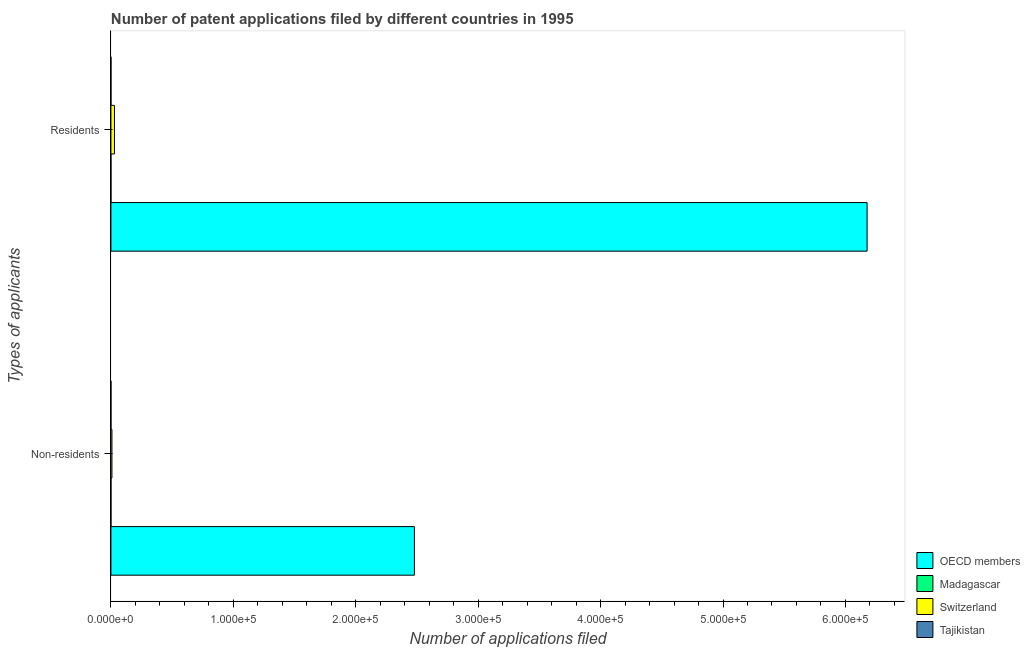How many different coloured bars are there?
Keep it short and to the point. 4. Are the number of bars per tick equal to the number of legend labels?
Offer a very short reply. Yes. Are the number of bars on each tick of the Y-axis equal?
Provide a succinct answer. Yes. How many bars are there on the 2nd tick from the top?
Give a very brief answer. 4. What is the label of the 2nd group of bars from the top?
Offer a terse response. Non-residents. What is the number of patent applications by non residents in OECD members?
Give a very brief answer. 2.48e+05. Across all countries, what is the maximum number of patent applications by residents?
Keep it short and to the point. 6.18e+05. Across all countries, what is the minimum number of patent applications by non residents?
Offer a very short reply. 16. In which country was the number of patent applications by non residents minimum?
Make the answer very short. Madagascar. What is the total number of patent applications by residents in the graph?
Give a very brief answer. 6.21e+05. What is the difference between the number of patent applications by non residents in Tajikistan and that in Switzerland?
Your response must be concise. -800. What is the difference between the number of patent applications by non residents in Switzerland and the number of patent applications by residents in OECD members?
Offer a terse response. -6.17e+05. What is the average number of patent applications by residents per country?
Give a very brief answer. 1.55e+05. What is the difference between the number of patent applications by residents and number of patent applications by non residents in OECD members?
Your answer should be very brief. 3.70e+05. In how many countries, is the number of patent applications by residents greater than 600000 ?
Your answer should be compact. 1. What is the ratio of the number of patent applications by residents in Madagascar to that in Switzerland?
Your answer should be compact. 0.01. Is the number of patent applications by residents in Tajikistan less than that in Madagascar?
Offer a very short reply. No. In how many countries, is the number of patent applications by non residents greater than the average number of patent applications by non residents taken over all countries?
Give a very brief answer. 1. What does the 2nd bar from the top in Residents represents?
Give a very brief answer. Switzerland. What does the 2nd bar from the bottom in Residents represents?
Provide a short and direct response. Madagascar. How many countries are there in the graph?
Your answer should be compact. 4. What is the difference between two consecutive major ticks on the X-axis?
Provide a short and direct response. 1.00e+05. What is the title of the graph?
Make the answer very short. Number of patent applications filed by different countries in 1995. Does "Belarus" appear as one of the legend labels in the graph?
Ensure brevity in your answer.  No. What is the label or title of the X-axis?
Keep it short and to the point. Number of applications filed. What is the label or title of the Y-axis?
Your answer should be compact. Types of applicants. What is the Number of applications filed in OECD members in Non-residents?
Your answer should be very brief. 2.48e+05. What is the Number of applications filed of Switzerland in Non-residents?
Provide a short and direct response. 830. What is the Number of applications filed in Tajikistan in Non-residents?
Provide a succinct answer. 30. What is the Number of applications filed of OECD members in Residents?
Make the answer very short. 6.18e+05. What is the Number of applications filed of Switzerland in Residents?
Your response must be concise. 2890. What is the Number of applications filed of Tajikistan in Residents?
Make the answer very short. 35. Across all Types of applicants, what is the maximum Number of applications filed of OECD members?
Your answer should be very brief. 6.18e+05. Across all Types of applicants, what is the maximum Number of applications filed in Switzerland?
Offer a very short reply. 2890. Across all Types of applicants, what is the maximum Number of applications filed in Tajikistan?
Your response must be concise. 35. Across all Types of applicants, what is the minimum Number of applications filed of OECD members?
Provide a short and direct response. 2.48e+05. Across all Types of applicants, what is the minimum Number of applications filed of Switzerland?
Your answer should be compact. 830. Across all Types of applicants, what is the minimum Number of applications filed of Tajikistan?
Give a very brief answer. 30. What is the total Number of applications filed in OECD members in the graph?
Your answer should be compact. 8.66e+05. What is the total Number of applications filed of Switzerland in the graph?
Your response must be concise. 3720. What is the difference between the Number of applications filed in OECD members in Non-residents and that in Residents?
Provide a succinct answer. -3.70e+05. What is the difference between the Number of applications filed in Madagascar in Non-residents and that in Residents?
Give a very brief answer. -6. What is the difference between the Number of applications filed of Switzerland in Non-residents and that in Residents?
Provide a short and direct response. -2060. What is the difference between the Number of applications filed of OECD members in Non-residents and the Number of applications filed of Madagascar in Residents?
Ensure brevity in your answer.  2.48e+05. What is the difference between the Number of applications filed in OECD members in Non-residents and the Number of applications filed in Switzerland in Residents?
Provide a succinct answer. 2.45e+05. What is the difference between the Number of applications filed of OECD members in Non-residents and the Number of applications filed of Tajikistan in Residents?
Give a very brief answer. 2.48e+05. What is the difference between the Number of applications filed of Madagascar in Non-residents and the Number of applications filed of Switzerland in Residents?
Offer a very short reply. -2874. What is the difference between the Number of applications filed in Switzerland in Non-residents and the Number of applications filed in Tajikistan in Residents?
Your response must be concise. 795. What is the average Number of applications filed of OECD members per Types of applicants?
Give a very brief answer. 4.33e+05. What is the average Number of applications filed of Madagascar per Types of applicants?
Give a very brief answer. 19. What is the average Number of applications filed in Switzerland per Types of applicants?
Your response must be concise. 1860. What is the average Number of applications filed of Tajikistan per Types of applicants?
Your answer should be compact. 32.5. What is the difference between the Number of applications filed in OECD members and Number of applications filed in Madagascar in Non-residents?
Offer a terse response. 2.48e+05. What is the difference between the Number of applications filed in OECD members and Number of applications filed in Switzerland in Non-residents?
Your response must be concise. 2.47e+05. What is the difference between the Number of applications filed in OECD members and Number of applications filed in Tajikistan in Non-residents?
Keep it short and to the point. 2.48e+05. What is the difference between the Number of applications filed of Madagascar and Number of applications filed of Switzerland in Non-residents?
Make the answer very short. -814. What is the difference between the Number of applications filed in Switzerland and Number of applications filed in Tajikistan in Non-residents?
Provide a short and direct response. 800. What is the difference between the Number of applications filed of OECD members and Number of applications filed of Madagascar in Residents?
Keep it short and to the point. 6.18e+05. What is the difference between the Number of applications filed of OECD members and Number of applications filed of Switzerland in Residents?
Your response must be concise. 6.15e+05. What is the difference between the Number of applications filed in OECD members and Number of applications filed in Tajikistan in Residents?
Offer a very short reply. 6.18e+05. What is the difference between the Number of applications filed in Madagascar and Number of applications filed in Switzerland in Residents?
Give a very brief answer. -2868. What is the difference between the Number of applications filed of Switzerland and Number of applications filed of Tajikistan in Residents?
Ensure brevity in your answer.  2855. What is the ratio of the Number of applications filed of OECD members in Non-residents to that in Residents?
Ensure brevity in your answer.  0.4. What is the ratio of the Number of applications filed of Madagascar in Non-residents to that in Residents?
Your answer should be compact. 0.73. What is the ratio of the Number of applications filed in Switzerland in Non-residents to that in Residents?
Ensure brevity in your answer.  0.29. What is the difference between the highest and the second highest Number of applications filed in OECD members?
Provide a succinct answer. 3.70e+05. What is the difference between the highest and the second highest Number of applications filed in Madagascar?
Offer a very short reply. 6. What is the difference between the highest and the second highest Number of applications filed of Switzerland?
Make the answer very short. 2060. What is the difference between the highest and the second highest Number of applications filed in Tajikistan?
Your answer should be very brief. 5. What is the difference between the highest and the lowest Number of applications filed of OECD members?
Provide a succinct answer. 3.70e+05. What is the difference between the highest and the lowest Number of applications filed in Switzerland?
Provide a succinct answer. 2060. 